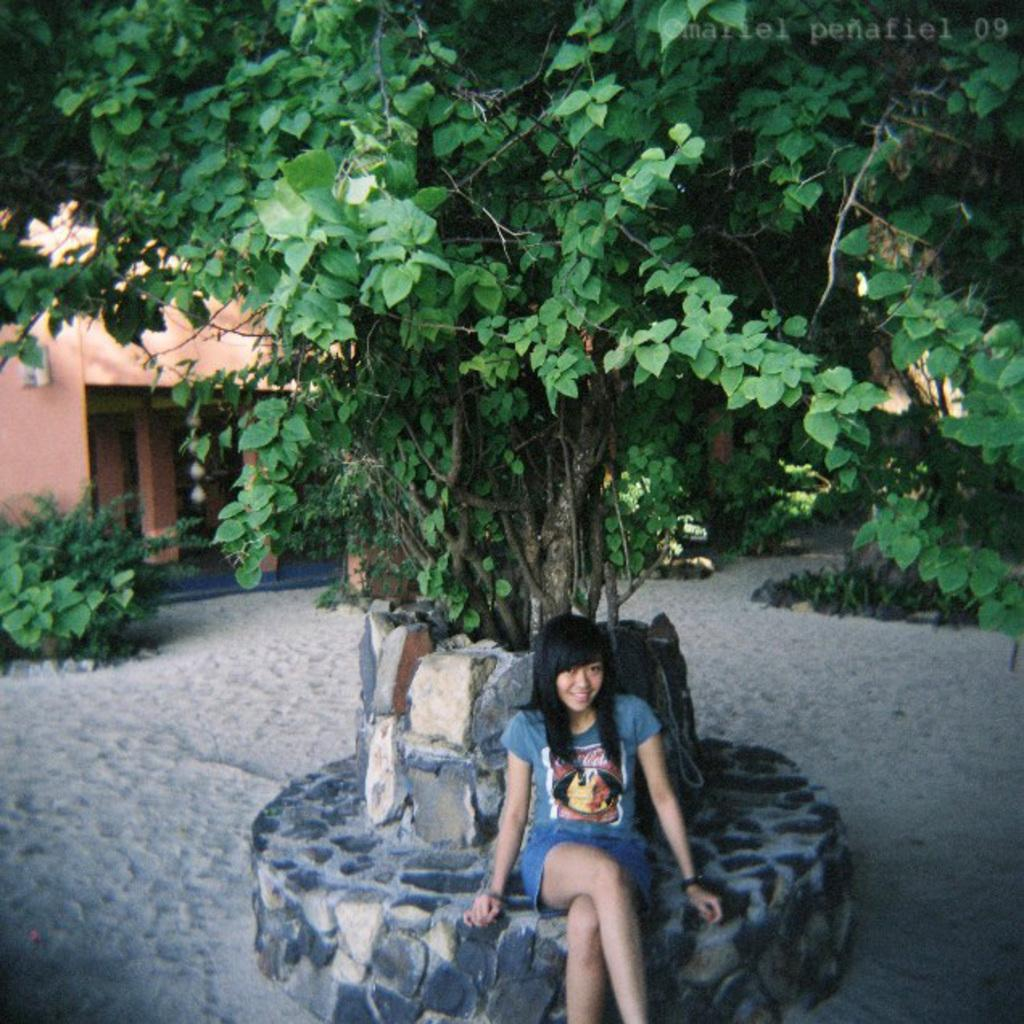What is the person in the image doing? The person is sitting on an object in the image. What can be seen in the background of the image? There is a tree, some objects, and a house in the image. What type of terrain is visible in the image? The ground with some sand is visible in the image. What other natural elements are present in the image? There are plants in the image. What type of oven can be seen in the image? There is no oven present in the image. How does the person in the image say good-bye to the others? The image does not show any interaction between the person and others, so it is not possible to determine how they say good-bye. 